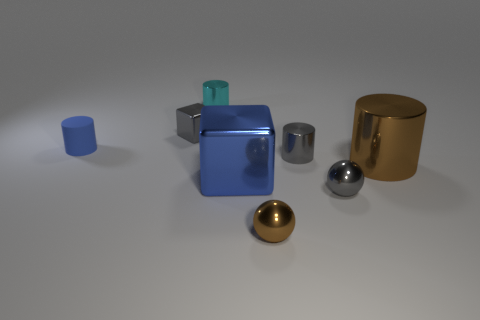Are there any gray objects that have the same shape as the cyan thing?
Your response must be concise. Yes. Does the blue object that is right of the small cyan cylinder have the same shape as the thing on the left side of the gray block?
Your response must be concise. No. What shape is the gray metal object that is behind the large brown metallic thing and to the right of the tiny brown shiny object?
Make the answer very short. Cylinder. Are there any gray cylinders that have the same size as the brown cylinder?
Provide a short and direct response. No. Is the color of the small block the same as the big metal object left of the brown shiny cylinder?
Offer a very short reply. No. What is the material of the big brown cylinder?
Keep it short and to the point. Metal. There is a shiny cylinder that is behind the gray block; what color is it?
Offer a terse response. Cyan. What number of tiny matte objects are the same color as the big metallic block?
Make the answer very short. 1. What number of things are both to the right of the small blue matte cylinder and to the left of the gray metallic cube?
Your response must be concise. 0. There is a brown metal thing that is the same size as the cyan shiny cylinder; what shape is it?
Your answer should be compact. Sphere. 